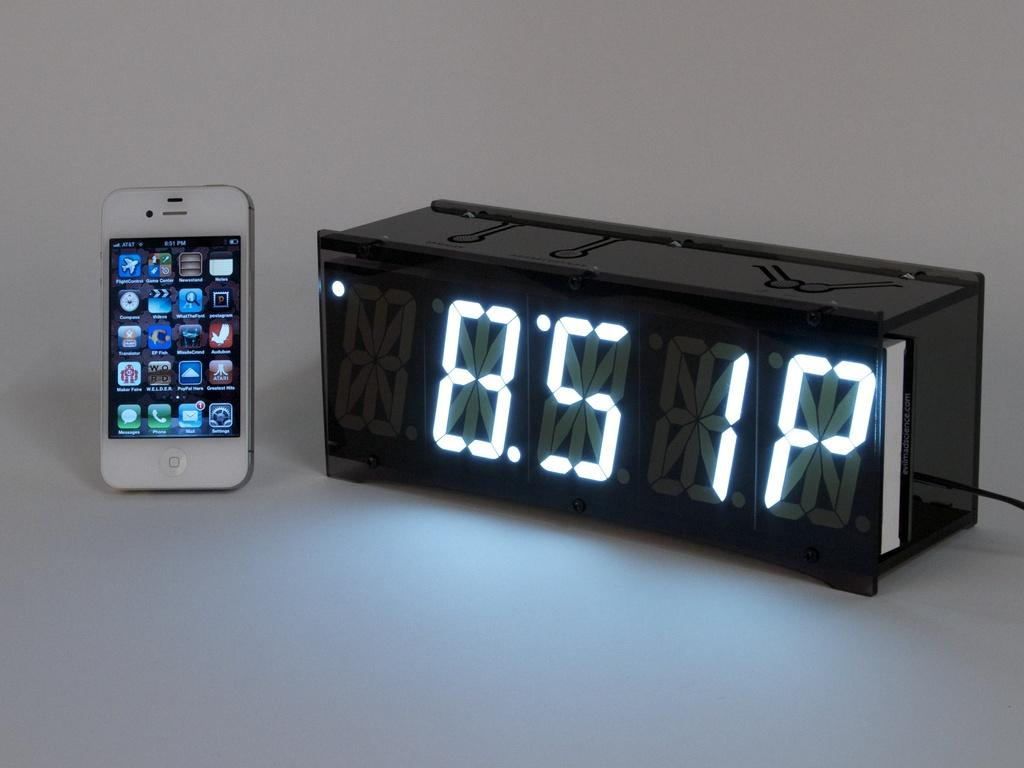<image>
Create a compact narrative representing the image presented. An AT&T cellphone and a digital clock reading 8:51 P 